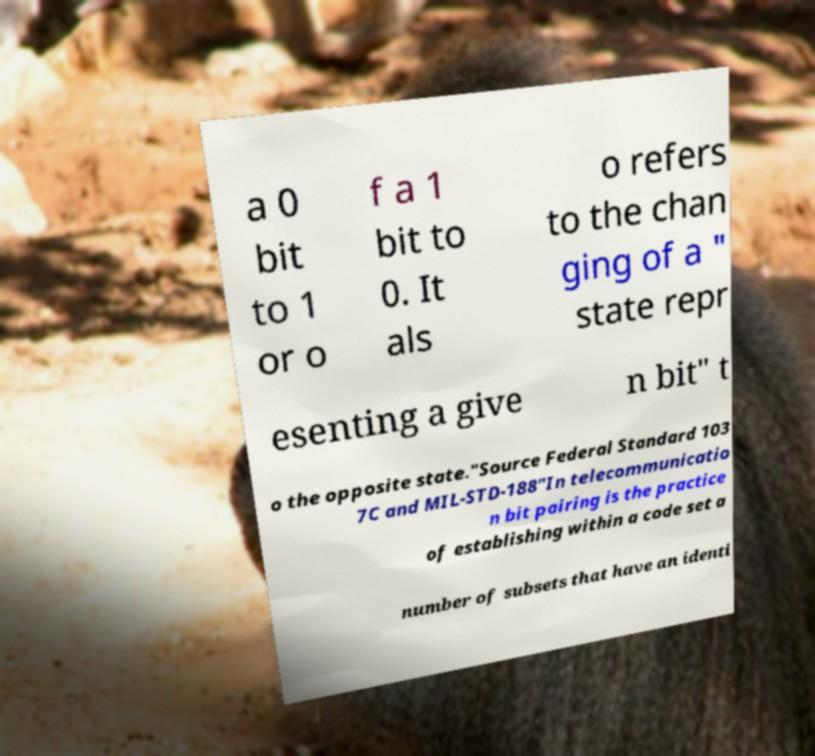I need the written content from this picture converted into text. Can you do that? a 0 bit to 1 or o f a 1 bit to 0. It als o refers to the chan ging of a " state repr esenting a give n bit" t o the opposite state."Source Federal Standard 103 7C and MIL-STD-188"In telecommunicatio n bit pairing is the practice of establishing within a code set a number of subsets that have an identi 